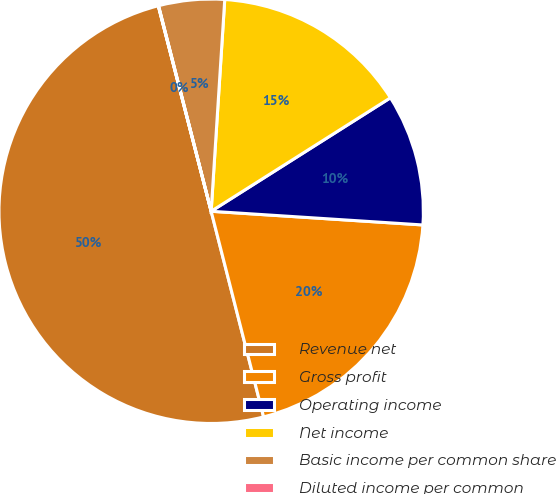Convert chart. <chart><loc_0><loc_0><loc_500><loc_500><pie_chart><fcel>Revenue net<fcel>Gross profit<fcel>Operating income<fcel>Net income<fcel>Basic income per common share<fcel>Diluted income per common<nl><fcel>49.97%<fcel>20.0%<fcel>10.01%<fcel>15.0%<fcel>5.01%<fcel>0.02%<nl></chart> 